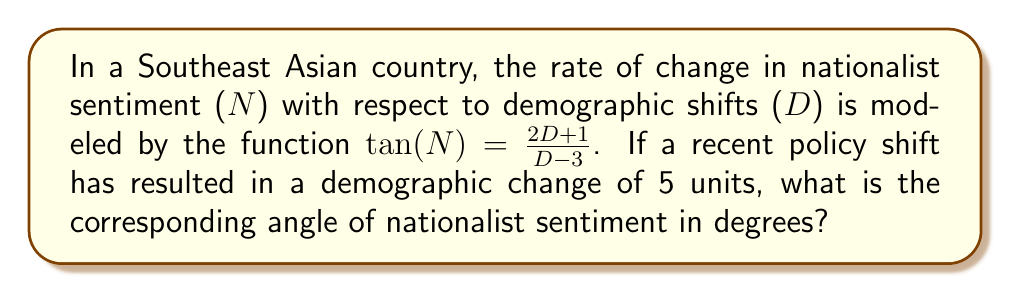Solve this math problem. To solve this problem, we need to follow these steps:

1) We are given that $\tan(N) = \frac{2D + 1}{D - 3}$

2) We need to substitute D = 5 into this equation:

   $\tan(N) = \frac{2(5) + 1}{5 - 3} = \frac{11}{2}$

3) Now we have $\tan(N) = \frac{11}{2}$

4) To find N, we need to use the inverse tangent function (arctan or $\tan^{-1}$):

   $N = \tan^{-1}(\frac{11}{2})$

5) Using a calculator or computer, we can evaluate this:

   $N \approx 1.3909$ radians

6) The question asks for the answer in degrees, so we need to convert:

   $N_{degrees} = N_{radians} \cdot \frac{180°}{\pi}$

   $N_{degrees} \approx 1.3909 \cdot \frac{180°}{\pi} \approx 79.70°$

Therefore, the angle of nationalist sentiment is approximately 79.70°.
Answer: 79.70° 